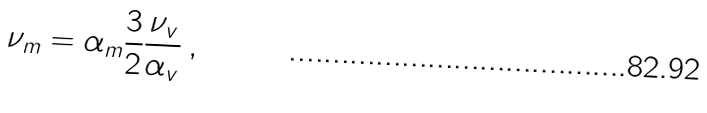<formula> <loc_0><loc_0><loc_500><loc_500>\nu _ { m } = \alpha _ { m } \frac { 3 } { 2 } \frac { \nu _ { v } } { \alpha _ { v } } \, ,</formula> 